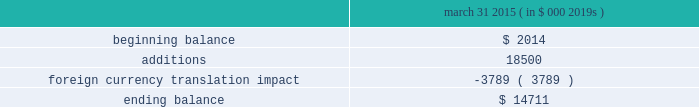Abiomed , inc .
And subsidiaries notes to consolidated financial statements 2014 ( continued ) note 8 .
Goodwill and in-process research and development ( continued ) the company has no accumulated impairment losses on goodwill .
The company performed a step 0 qualitative assessment during the annual impairment review for fiscal 2015 as of october 31 , 2014 and concluded that it is not more likely than not that the fair value of the company 2019s single reporting unit is less than its carrying amount .
Therefore , the two-step goodwill impairment test for the reporting unit was not necessary in fiscal 2015 .
As described in note 3 .
201cacquisitions , 201d in july 2014 , the company acquired ecp and ais and recorded $ 18.5 million of ipr&d .
The estimated fair value of the ipr&d was determined using a probability-weighted income approach , which discounts expected future cash flows to present value .
The projected cash flows from the expandable catheter pump technology were based on certain key assumptions , including estimates of future revenue and expenses , taking into account the stage of development of the technology at the acquisition date and the time and resources needed to complete development .
The company used a discount rate of 22.5% ( 22.5 % ) and cash flows that have been probability adjusted to reflect the risks of product commercialization , which the company believes are appropriate and representative of market participant assumptions .
The carrying value of the company 2019s ipr&d assets and the change in the balance for the year ended march 31 , 2015 is as follows : march 31 , ( in $ 000 2019s ) .
Note 9 .
Stockholders 2019 equity class b preferred stock the company has authorized 1000000 shares of class b preferred stock , $ .01 par value , of which the board of directors can set the designation , rights and privileges .
No shares of class b preferred stock have been issued or are outstanding .
Stock repurchase program in november 2012 , the company 2019s board of directors authorized a stock repurchase program for up to $ 15.0 million of its common stock .
The company financed the stock repurchase program with its available cash .
During the year ended march 31 , 2013 , the company repurchased 1123587 shares for $ 15.0 million in open market purchases at an average cost of $ 13.39 per share , including commission expense .
The company completed the purchase of common stock under this stock repurchase program in january 2013 .
Note 10 .
Stock award plans and stock-based compensation stock award plans the company grants stock options and restricted stock awards to employees and others .
All outstanding stock options of the company as of march 31 , 2015 were granted with an exercise price equal to the fair market value on the date of grant .
Outstanding stock options , if not exercised , expire 10 years from the date of grant .
The company 2019s 2008 stock incentive plan ( the 201cplan 201d ) authorizes the grant of a variety of equity awards to the company 2019s officers , directors , employees , consultants and advisers , including awards of unrestricted and restricted stock , restricted stock units , incentive and nonqualified stock options to purchase shares of common stock , performance share awards and stock appreciation rights .
The plan provides that options may only be granted at the current market value on the date of grant .
Each share of stock issued pursuant to a stock option or stock appreciation right counts as one share against the maximum number of shares issuable under the plan , while each share of stock issued .
What percentage of the class b preferred stock is currently outstanding? 
Computations: (0 / 1000000)
Answer: 0.0. 